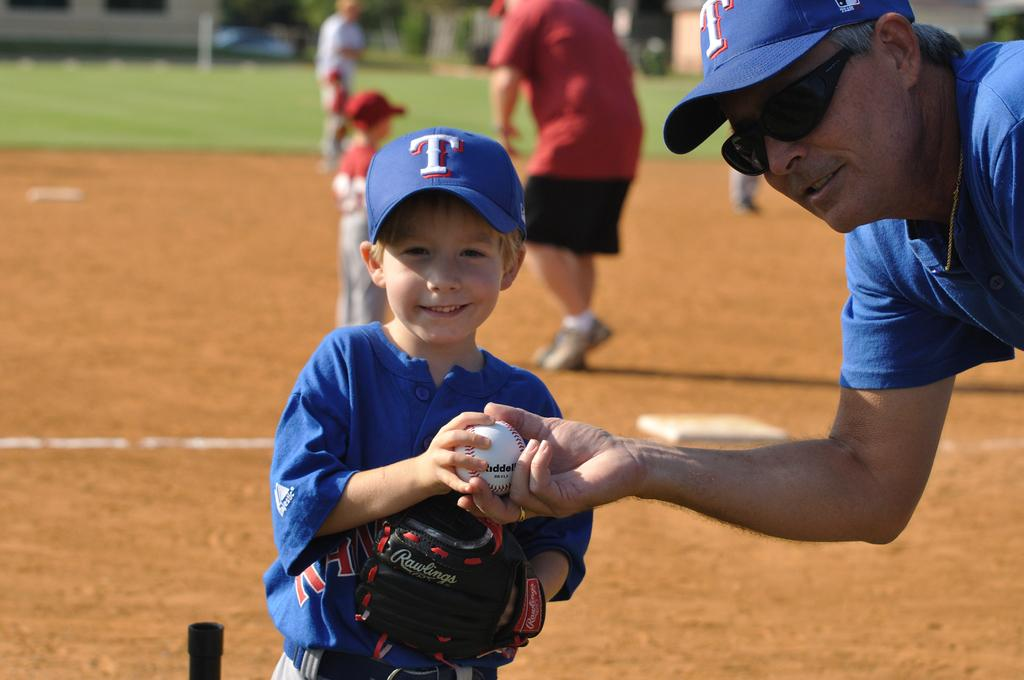<image>
Describe the image concisely. A man hands a baseball to a young boy wearing a blue hat with a white T on it. 